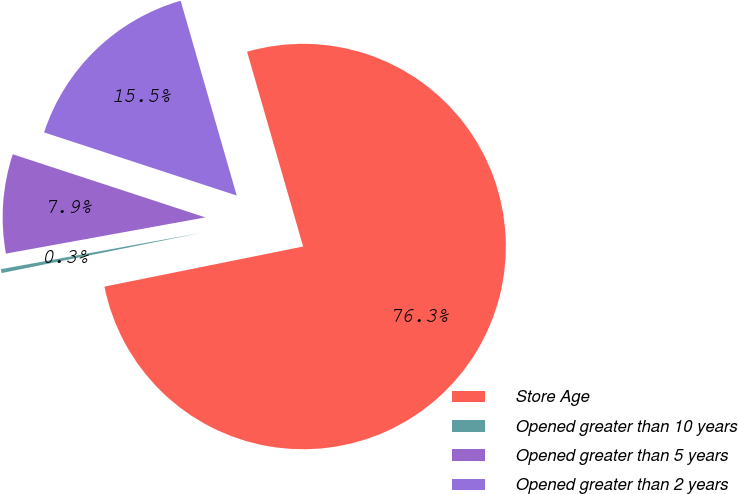<chart> <loc_0><loc_0><loc_500><loc_500><pie_chart><fcel>Store Age<fcel>Opened greater than 10 years<fcel>Opened greater than 5 years<fcel>Opened greater than 2 years<nl><fcel>76.29%<fcel>0.31%<fcel>7.9%<fcel>15.5%<nl></chart> 